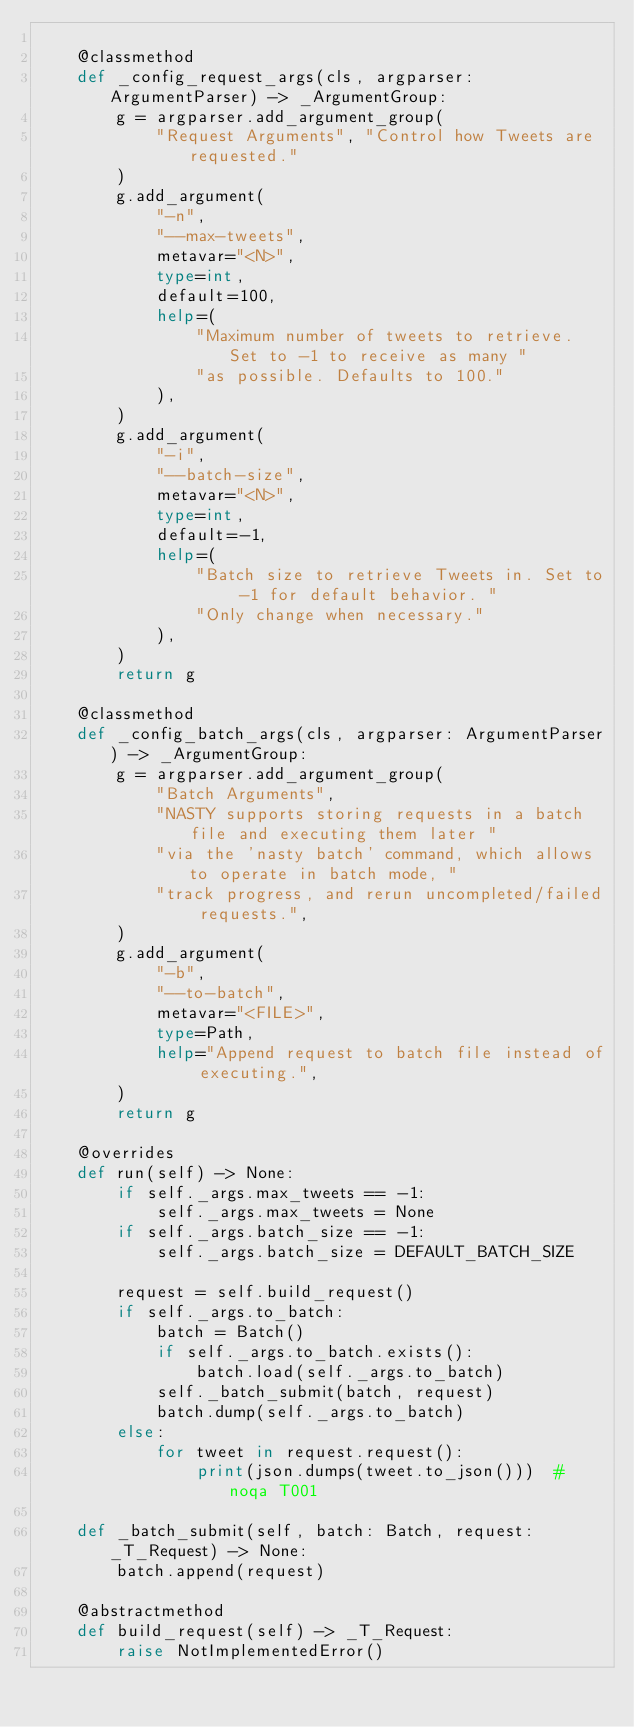<code> <loc_0><loc_0><loc_500><loc_500><_Python_>
    @classmethod
    def _config_request_args(cls, argparser: ArgumentParser) -> _ArgumentGroup:
        g = argparser.add_argument_group(
            "Request Arguments", "Control how Tweets are requested."
        )
        g.add_argument(
            "-n",
            "--max-tweets",
            metavar="<N>",
            type=int,
            default=100,
            help=(
                "Maximum number of tweets to retrieve. Set to -1 to receive as many "
                "as possible. Defaults to 100."
            ),
        )
        g.add_argument(
            "-i",
            "--batch-size",
            metavar="<N>",
            type=int,
            default=-1,
            help=(
                "Batch size to retrieve Tweets in. Set to -1 for default behavior. "
                "Only change when necessary."
            ),
        )
        return g

    @classmethod
    def _config_batch_args(cls, argparser: ArgumentParser) -> _ArgumentGroup:
        g = argparser.add_argument_group(
            "Batch Arguments",
            "NASTY supports storing requests in a batch file and executing them later "
            "via the 'nasty batch' command, which allows to operate in batch mode, "
            "track progress, and rerun uncompleted/failed requests.",
        )
        g.add_argument(
            "-b",
            "--to-batch",
            metavar="<FILE>",
            type=Path,
            help="Append request to batch file instead of executing.",
        )
        return g

    @overrides
    def run(self) -> None:
        if self._args.max_tweets == -1:
            self._args.max_tweets = None
        if self._args.batch_size == -1:
            self._args.batch_size = DEFAULT_BATCH_SIZE

        request = self.build_request()
        if self._args.to_batch:
            batch = Batch()
            if self._args.to_batch.exists():
                batch.load(self._args.to_batch)
            self._batch_submit(batch, request)
            batch.dump(self._args.to_batch)
        else:
            for tweet in request.request():
                print(json.dumps(tweet.to_json()))  # noqa T001

    def _batch_submit(self, batch: Batch, request: _T_Request) -> None:
        batch.append(request)

    @abstractmethod
    def build_request(self) -> _T_Request:
        raise NotImplementedError()
</code> 